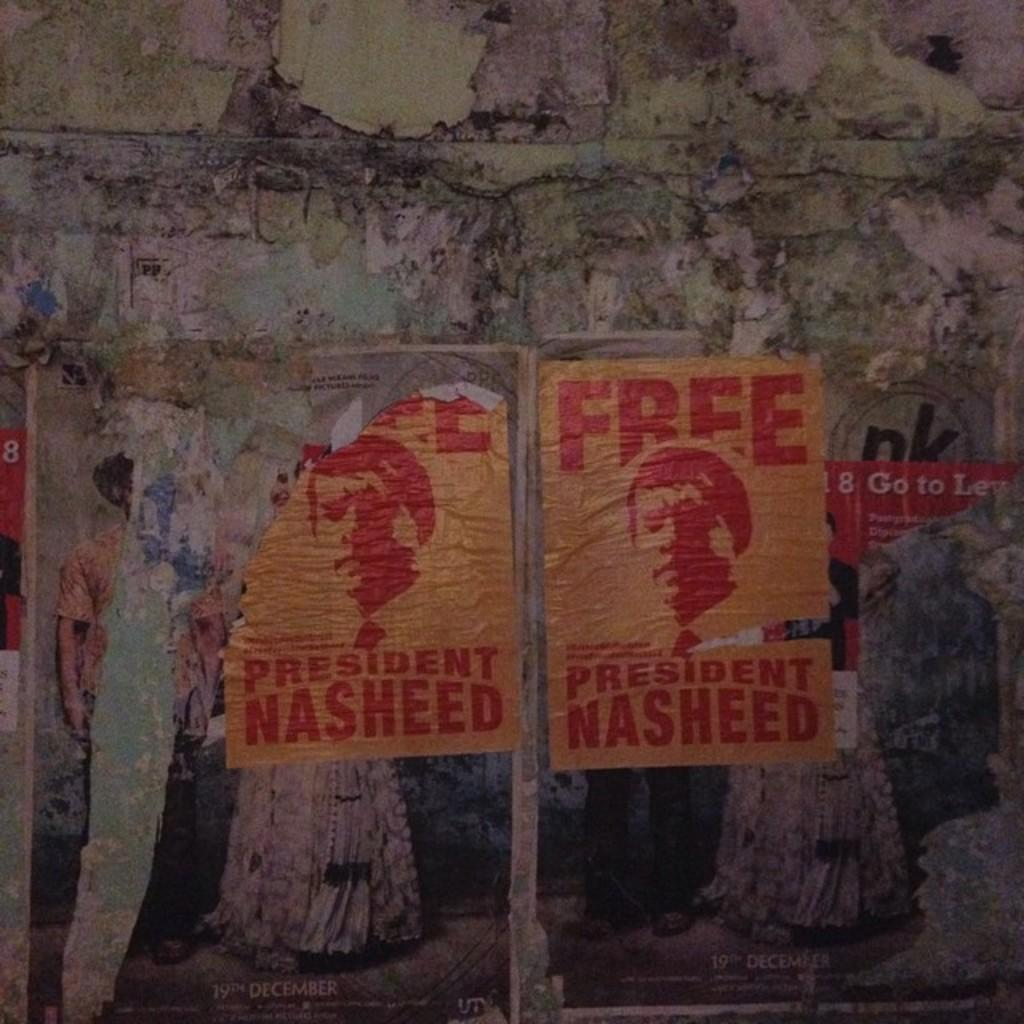Provide a one-sentence caption for the provided image. Free president Nasheed signs are posted on a wall. 